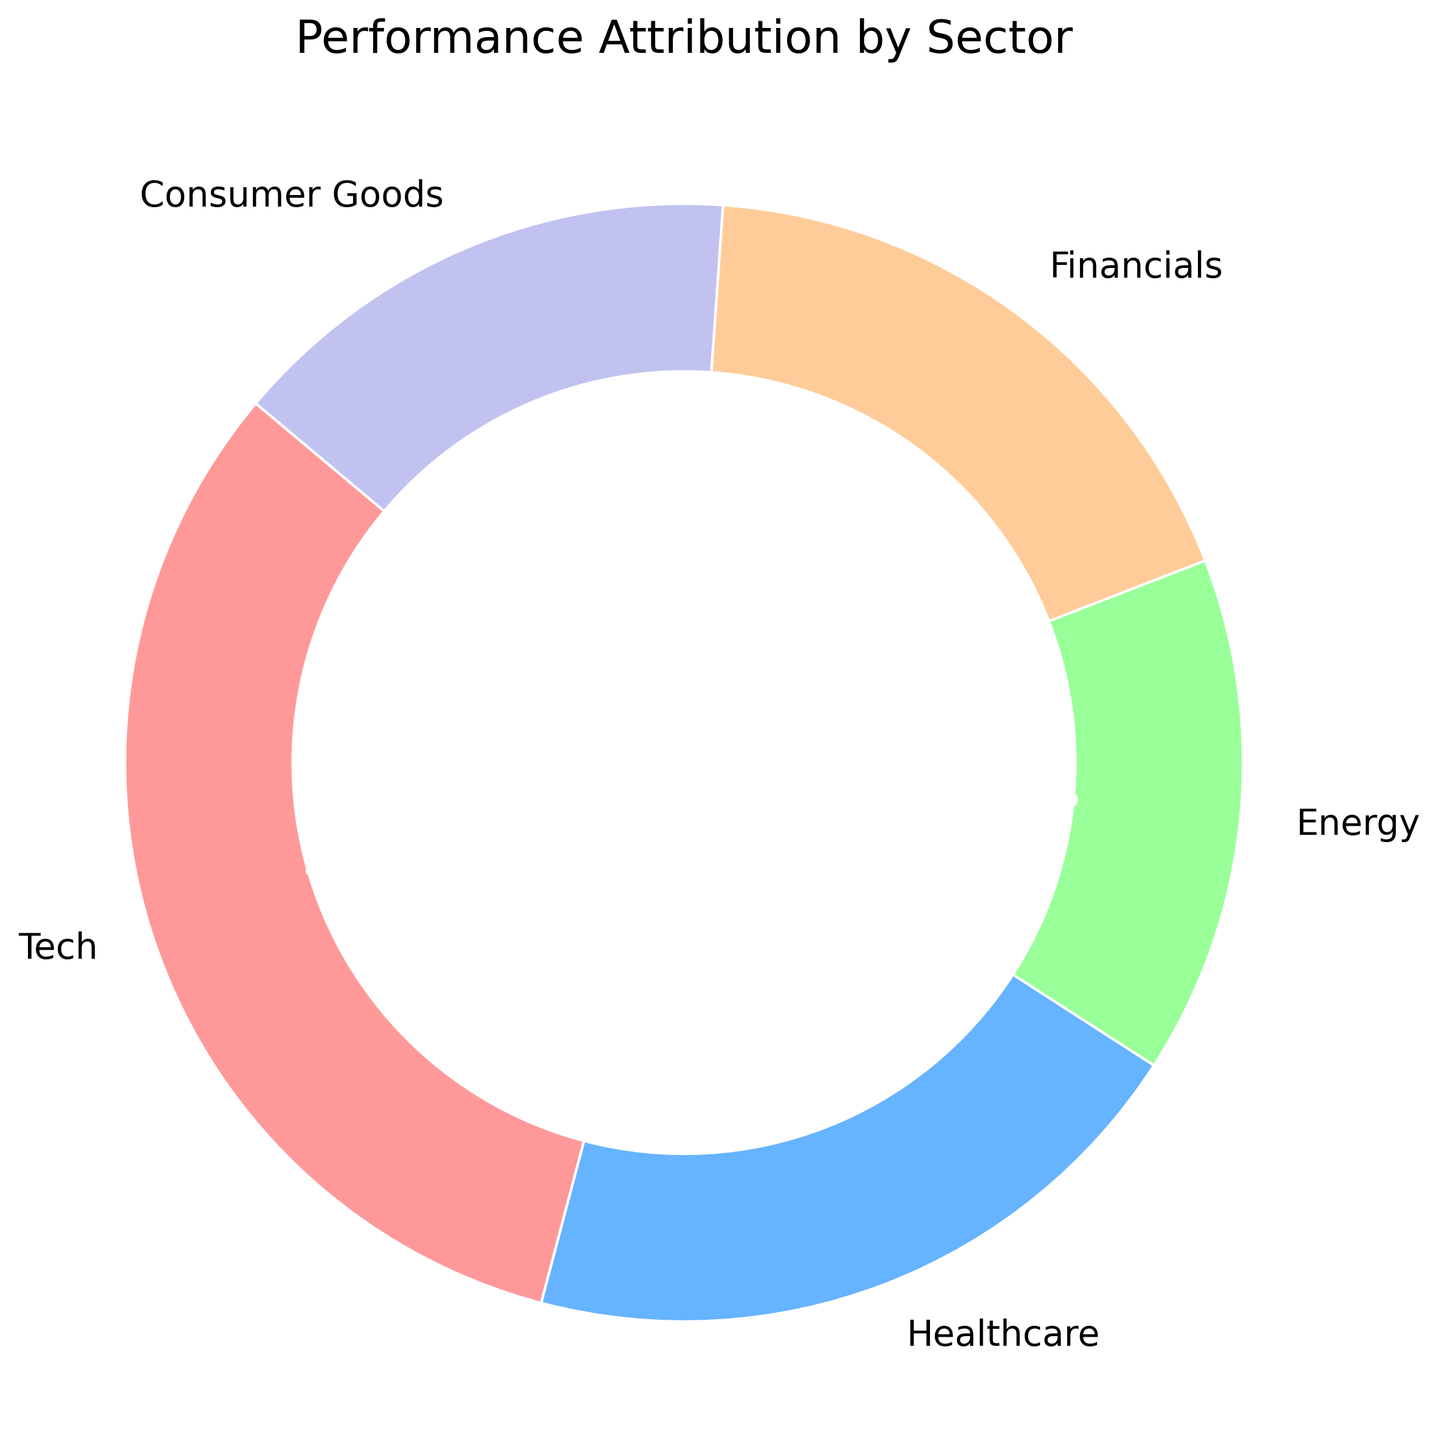What is the sector with the highest performance attribution? The sector with the highest performance attribution is identified by observing the slice with the largest percentage. In the figure, Tech has the largest slice at 32%, which is the highest among all the sectors.
Answer: Tech Which sector has an equal performance attribution to Energy? By referring to the labels and percentages in the chart, both Energy and Consumer Goods sectors each have a slice representing 15% of the total performance attribution.
Answer: Consumer Goods What is the difference in performance attribution between Tech and Financials? Tech has a performance attribution of 32%, and Financials have 18%. To find the difference, subtract Financials' percentage from Tech's percentage: 32% - 18% = 14%.
Answer: 14% What is the combined performance attribution of Healthcare and Consumer Goods? Healthcare has a performance attribution of 20%, and Consumer Goods has 15%. Adding these together: 20% + 15% = 35%.
Answer: 35% Which two sectors have the smallest performance attribution, and what is their combined percentage? The two sectors with the smallest performance attribution are Energy and Consumer Goods, both with 15%. Their combined percentage is: 15% + 15% = 30%.
Answer: Energy and Consumer Goods, 30% By what percentage is Tech's performance attribution greater than Healthcare's? Tech's performance attribution is 32%, and Healthcare's is 20%. The difference between these percentages is: 32% - 20% = 12%.
Answer: 12% What is the average performance attribution across all sectors? Adding up all the sectors' performance attributions: 32% (Tech) + 20% (Healthcare) + 15% (Energy) + 18% (Financials) + 15% (Consumer Goods) = 100%. Dividing by the number of sectors, 100% / 5 = 20%.
Answer: 20% What color is the sector with the smallest performance attribution? The sector with the smallest performance attribution is identified by checking the slices with the smallest percentage. Both Energy and Consumer Goods have the smallest performance attribution at 15%. In the chart, Energy is light blue, and Consumer Goods is purple. Detailed information on the exact smallest slice by color can be inferred.
Answer: Light blue (Energy) or Purple (Consumer Goods) If the combined performance attribution of Energy and Financials needs to be doubled, what would their new combined percentage be? First, calculate the current combined percentage of Energy (15%) and Financials (18%): 15% + 18% = 33%. Doubling this combined percentage: 33% × 2 = 66%.
Answer: 66% List the sectors in descending order of performance attribution. To list the sectors in descending order, rank the percentages from highest to lowest: Tech (32%), Healthcare (20%), Financials (18%), Energy (15%), Consumer Goods (15%).
Answer: Tech, Healthcare, Financials, Energy, Consumer Goods 